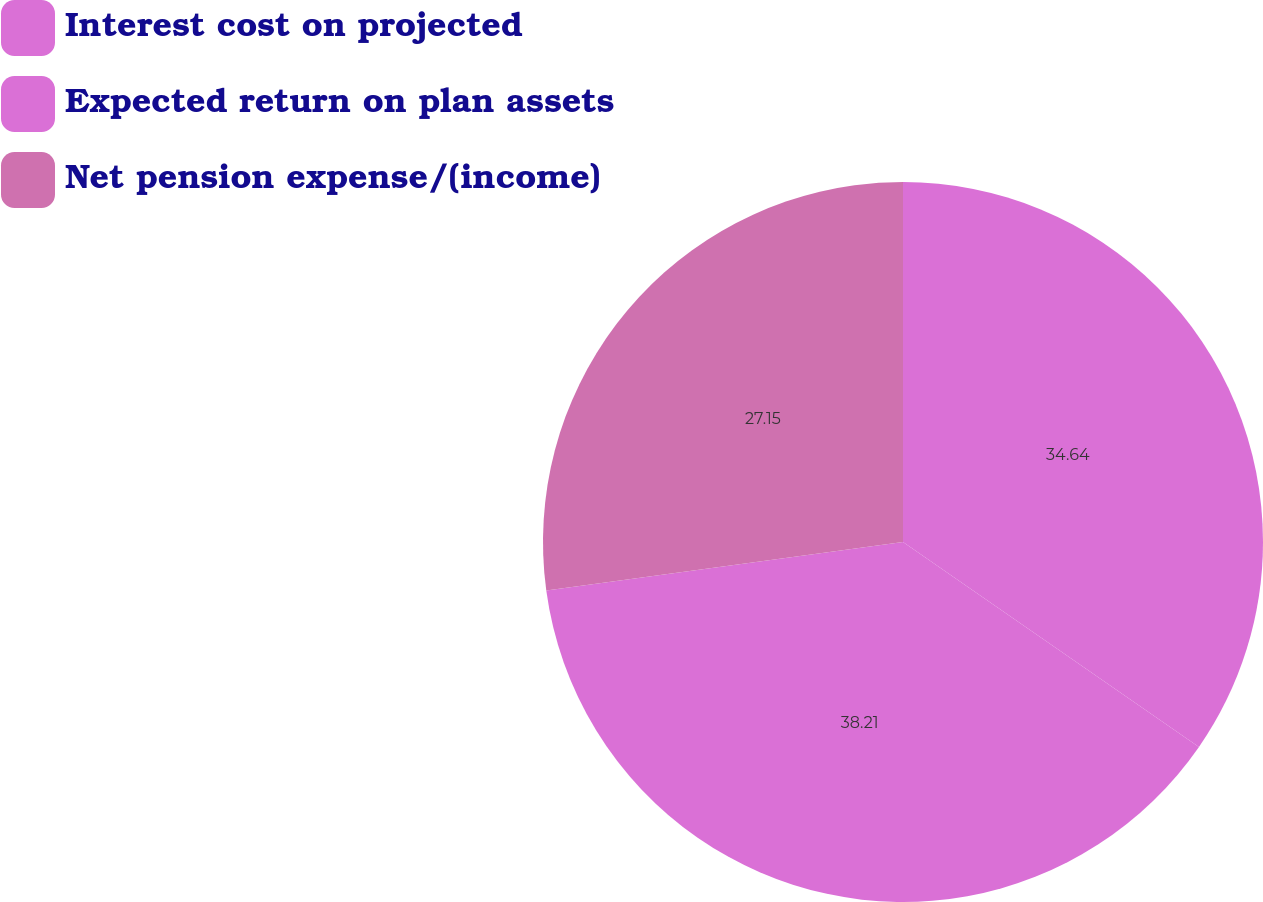Convert chart to OTSL. <chart><loc_0><loc_0><loc_500><loc_500><pie_chart><fcel>Interest cost on projected<fcel>Expected return on plan assets<fcel>Net pension expense/(income)<nl><fcel>34.64%<fcel>38.21%<fcel>27.15%<nl></chart> 